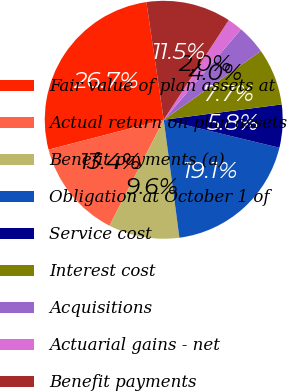Convert chart to OTSL. <chart><loc_0><loc_0><loc_500><loc_500><pie_chart><fcel>Fair value of plan assets at<fcel>Actual return on plan assets<fcel>Benefit payments (a)<fcel>Obligation at October 1 of<fcel>Service cost<fcel>Interest cost<fcel>Acquisitions<fcel>Actuarial gains - net<fcel>Benefit payments<nl><fcel>26.7%<fcel>13.43%<fcel>9.64%<fcel>19.12%<fcel>5.84%<fcel>7.74%<fcel>3.95%<fcel>2.05%<fcel>11.53%<nl></chart> 